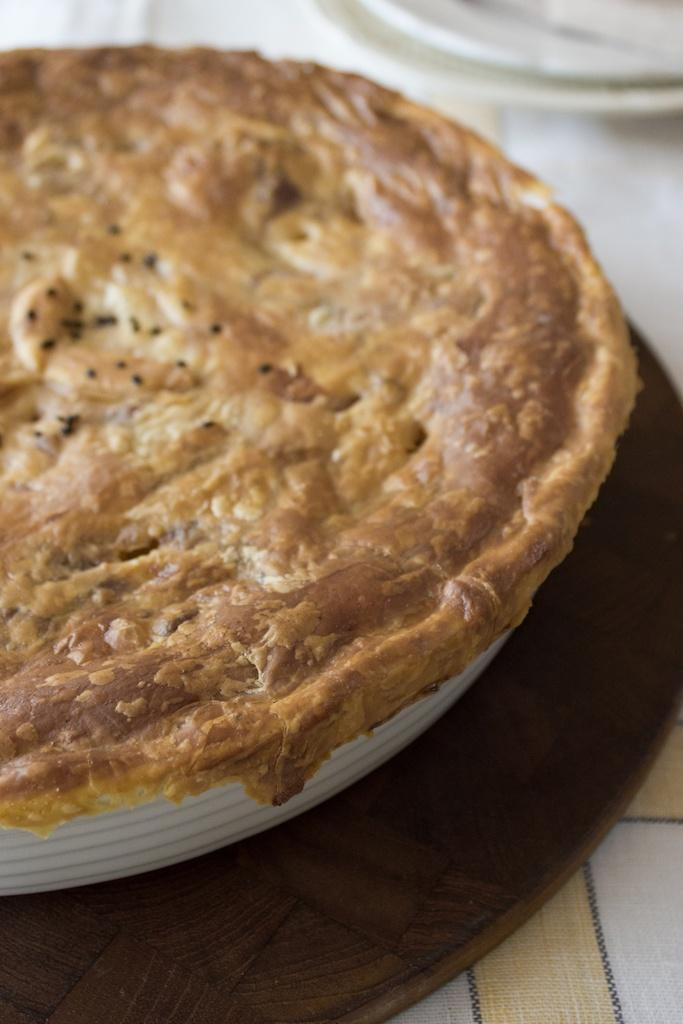What is the main subject in the center of the image? There is a food item in a plate in the center of the image. What is located at the bottom of the image? There is a table at the bottom of the image. What is covering the table in the image? There is a cloth on the table. What type of thunder can be heard in the image? There is no thunder present in the image, as it is a still image and not an audio recording. 